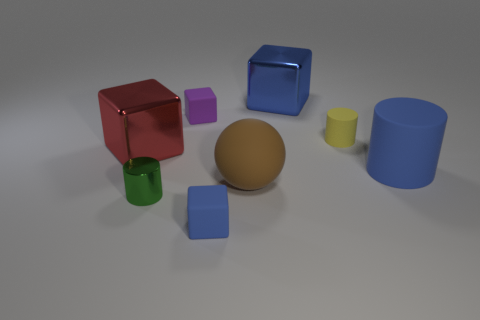Subtract all blue cylinders. How many blue cubes are left? 2 Subtract all red blocks. How many blocks are left? 3 Subtract all purple cubes. How many cubes are left? 3 Subtract 1 cylinders. How many cylinders are left? 2 Add 2 big green cylinders. How many objects exist? 10 Subtract all red cylinders. Subtract all brown balls. How many cylinders are left? 3 Subtract all spheres. How many objects are left? 7 Subtract all big blue cylinders. Subtract all tiny yellow matte cylinders. How many objects are left? 6 Add 4 blue blocks. How many blue blocks are left? 6 Add 5 red metallic things. How many red metallic things exist? 6 